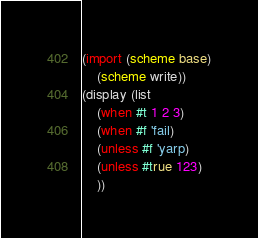<code> <loc_0><loc_0><loc_500><loc_500><_Scheme_>(import (scheme base)
    (scheme write))
(display (list
    (when #t 1 2 3)
    (when #f 'fail)
    (unless #f 'yarp)
    (unless #true 123)
    ))</code> 